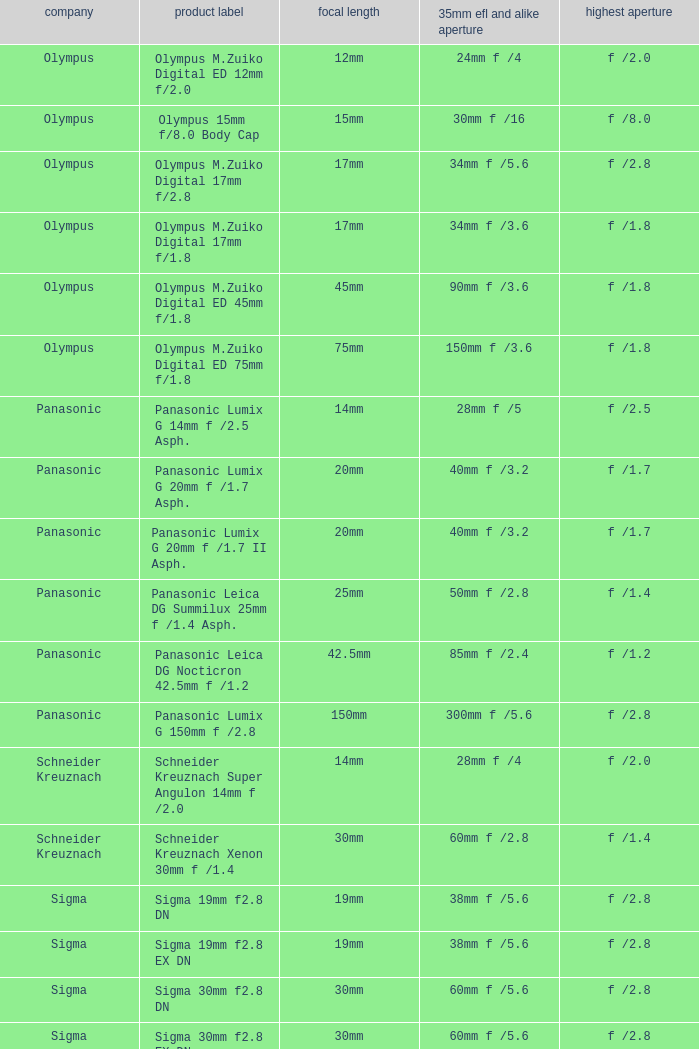What is the brand of the Sigma 30mm f2.8 DN, which has a maximum aperture of f /2.8 and a focal length of 30mm? Sigma. 